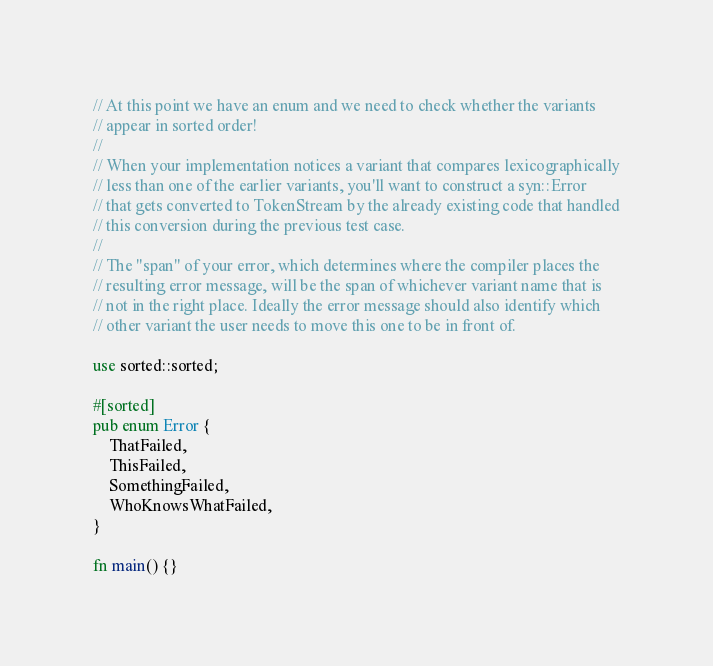Convert code to text. <code><loc_0><loc_0><loc_500><loc_500><_Rust_>// At this point we have an enum and we need to check whether the variants
// appear in sorted order!
//
// When your implementation notices a variant that compares lexicographically
// less than one of the earlier variants, you'll want to construct a syn::Error
// that gets converted to TokenStream by the already existing code that handled
// this conversion during the previous test case.
//
// The "span" of your error, which determines where the compiler places the
// resulting error message, will be the span of whichever variant name that is
// not in the right place. Ideally the error message should also identify which
// other variant the user needs to move this one to be in front of.

use sorted::sorted;

#[sorted]
pub enum Error {
    ThatFailed,
    ThisFailed,
    SomethingFailed,
    WhoKnowsWhatFailed,
}

fn main() {}
</code> 